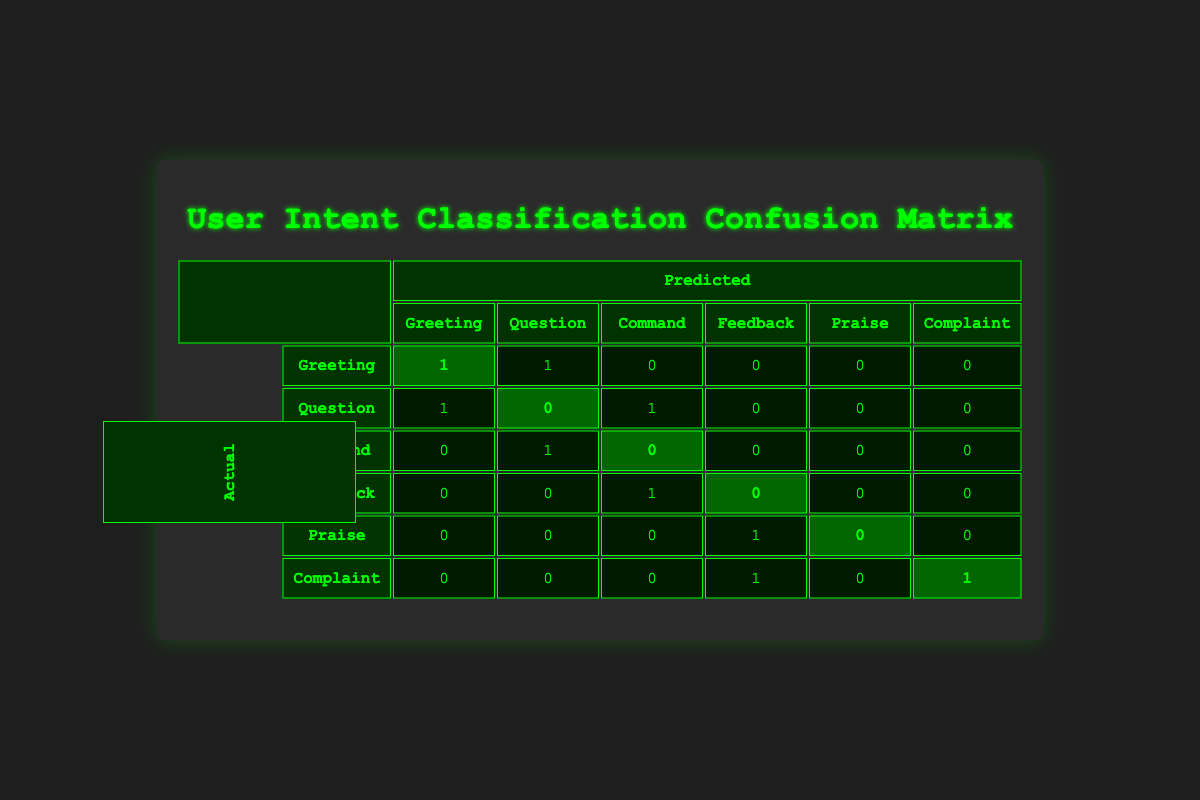What is the predicted label for the actual label "Greeting"? Looking at the row for "Greeting" in the actual labels, we see that there are 1 in the predicted column for "Greeting" and 1 for "Question". Therefore, the predicted label for "Greeting" is "Greeting".
Answer: Greeting How many instances were correctly classified for the label "Complaint"? The row for "Complaint" shows that there is 1 instance (highlighted) correctly predicted as "Complaint". Hence, the number of correctly classified instances for this label is 1.
Answer: 1 What is the total number of occurrences for the actual label "Question"? The occurrences for the actual label "Question" can be found in the second row. There is 1 correct prediction (highlighted) and 2 incorrect predictions. Adding these gives us a total of 3 occurrences for "Question".
Answer: 3 Is the predicted label "Command" for the actual label "Feedback"? In the row for actual label "Feedback", we see that the predicted label is "Command", which means that it is incorrectly classified. Thus, the prediction for this case is false.
Answer: False What is the total number of instances for the predicted label "Feedback"? We review each row in the "Feedback" column under predicted labels. There are 2 instances listed: one from the label "Command" and one from the label "Complaint". When totaled, the count gives us 2 instances for the predicted label "Feedback".
Answer: 2 What is the sum of all correctly predicted labels across all intent categories? We count the highlighted instances in each row, which are 1 (Greeting) + 0 (Question) + 0 (Command) + 0 (Feedback) + 1 (Praise) + 1 (Complaint). The total sums up to 3 correctly predicted labels overall.
Answer: 3 How many times was the label "Question" predicted incorrectly? In the row for the actual label "Question", we see 1 correct prediction (highlighted), while the predictions in "Greeting" and "Command" are incorrect. Since there are 2 incorrect predictions, the total count is 2.
Answer: 2 What is the difference in correctly classified instances between "Greeting" and "Praise"? The correctly classified instances for "Greeting" is 1 and for "Praise" is 1. The difference is 1 - 1 = 0, indicating they are equal.
Answer: 0 